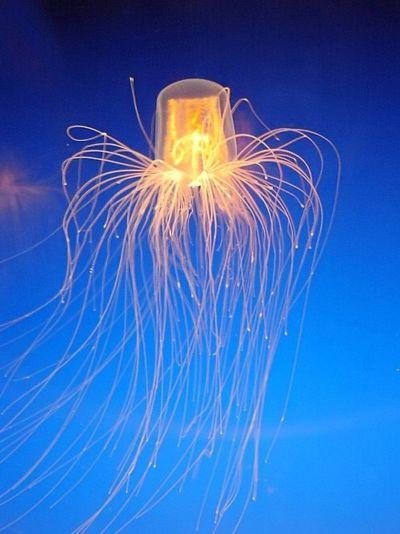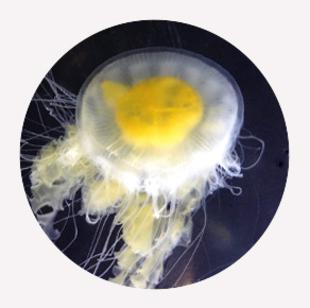The first image is the image on the left, the second image is the image on the right. Analyze the images presented: Is the assertion "the body of the jellyfish has dark stripes" valid? Answer yes or no. No. The first image is the image on the left, the second image is the image on the right. Analyze the images presented: Is the assertion "At least one jellyfish has a striped top." valid? Answer yes or no. No. 